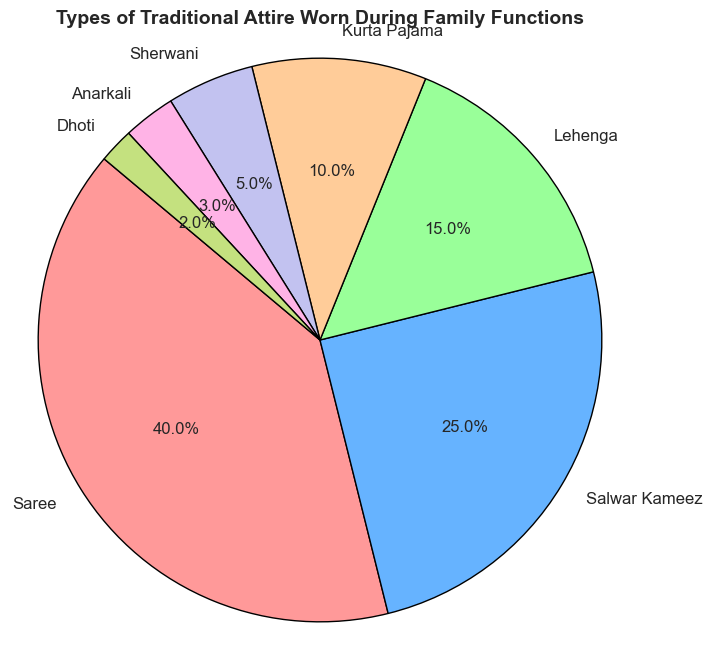What's the most commonly worn traditional attire during family functions? The figure shows a pie chart with various segments representing different types of traditional attire. The segment labeled "Saree" occupies the largest portion of the pie chart.
Answer: Saree How many percentage points more is Saree worn compared to Salwar Kameez? According to the pie chart, Saree has a percentage of 40% and Salwar Kameez has 25%. The difference between the two is 40 - 25 = 15 percentage points.
Answer: 15 percentage points Which two attires combined make up more than 50% of the attire worn? Inspecting the pie chart, Saree at 40% and Salwar Kameez at 25% together sum up to 65%. Therefore, these two attires combined make more than 50%.
Answer: Saree and Salwar Kameez What's the total percentage of attires worn that are not for males? From the pie chart, the male attires listed are Kurta Pajama (10%), Sherwani (5%), and Dhoti (2%). The total for male attires is 10 + 5 + 2 = 17%. Hence, the percentage of non-male attires is 100 - 17 = 83%.
Answer: 83% Which attire is worn the least during family functions and by what percentage? Looking at the pie chart, Dhoti has the smallest segment, representing only 2% of the total.
Answer: Dhoti, 2% What is the combined percentage of attires with less than 5% representation? The pie chart shows Sherwani at 5%, Anarkali at 3%, and Dhoti at 2%. Summing these percentages results in 5 + 3 + 2 = 10%.
Answer: 10% How does the percentage of Lehenga compare to that of Anarkali? The pie chart reveals that Lehenga comprises 15% whereas Anarkali makes up 3%. Comparing these, Lehenga has a higher percentage.
Answer: Lehenga has a higher percentage If we combine the percentages of Salwar Kameez and Kurta Pajama, do they make up more or less than half of the total attire worn? From the pie chart, Salwar Kameez is 25% and Kurta Pajama is 10%. Combining these gives 25 + 10 = 35%, which is less than 50%.
Answer: Less Which attire segment is represented by the light green color in the pie chart? From the description of the colors used in the pie chart, light green corresponds to the segment labeled as Dhoti.
Answer: Dhoti 